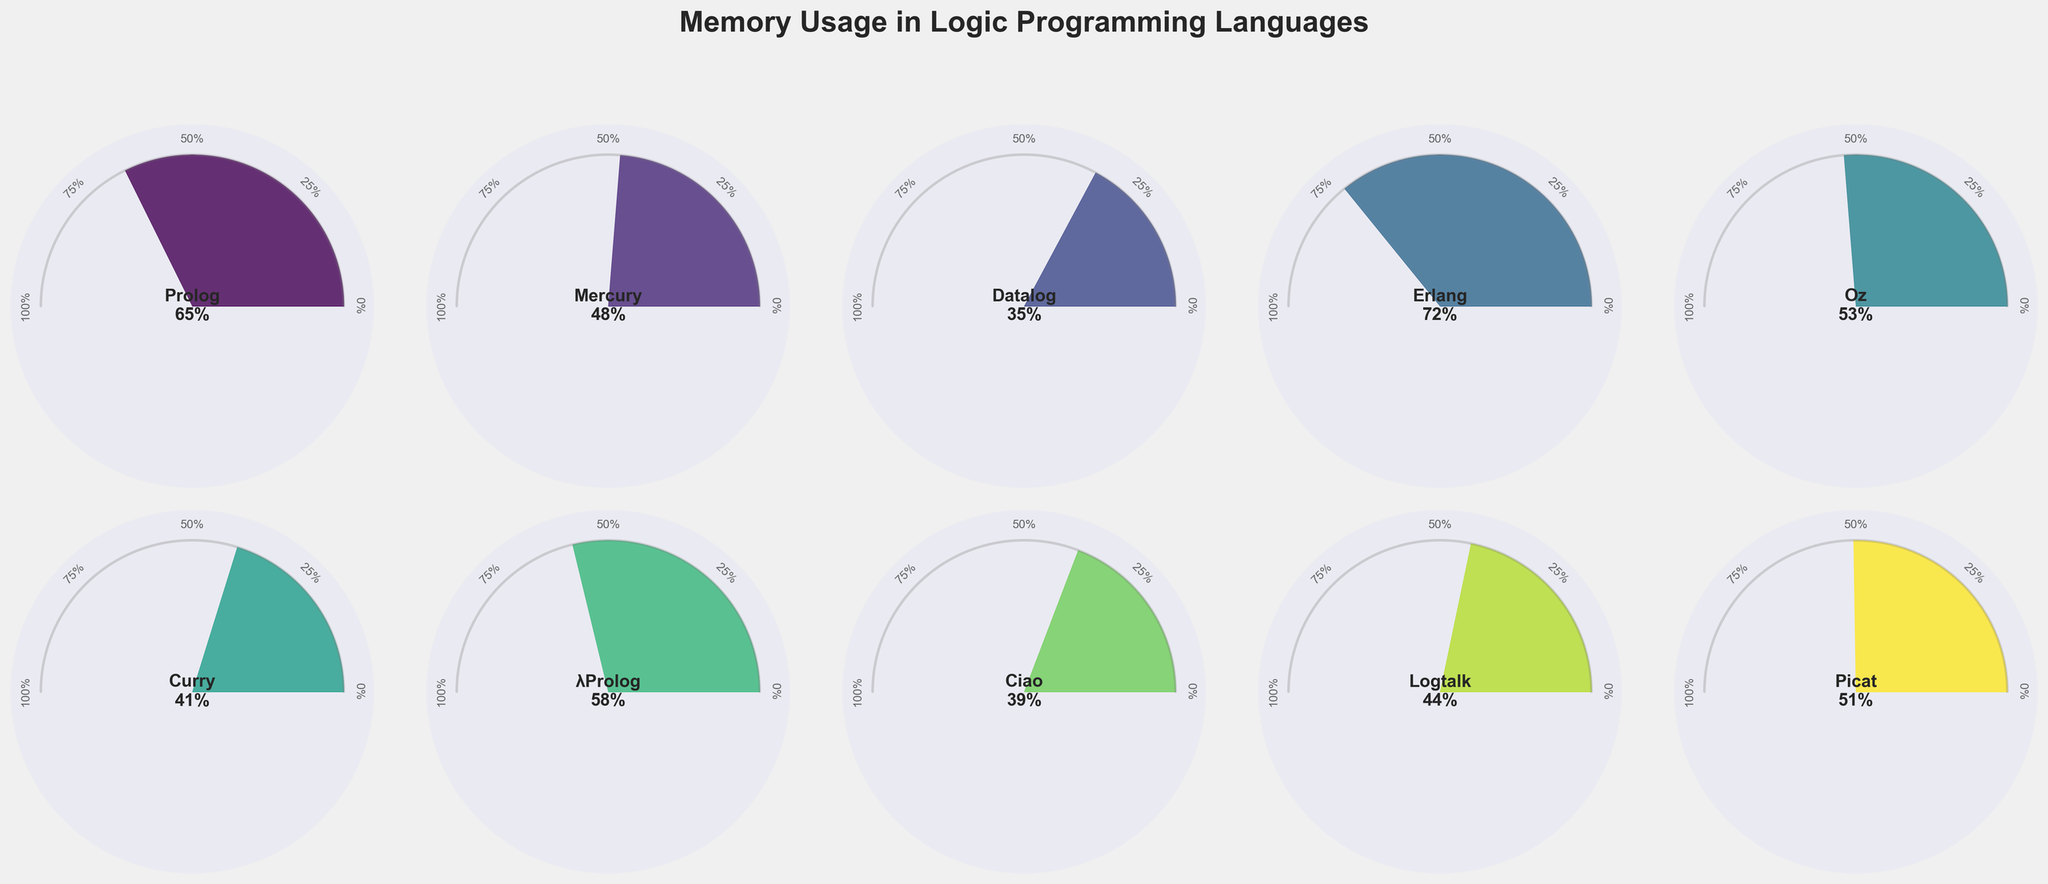Which logic programming language has the highest memory usage percentage? To find the language with the highest memory usage, scan the gauge charts and identify the one with the largest filled area. This corresponds to the language 'Erlang' that has 72% memory usage.
Answer: Erlang What is the average memory usage percentage across all languages? Add the memory usage percentages of all languages: 65 + 48 + 35 + 72 + 53 + 41 + 58 + 39 + 44 + 51 = 506. Then, divide by the number of languages, which is 10. The average memory usage is 506/10 = 50.6%.
Answer: 50.6% How many languages have a memory usage percentage higher than 50%? Count the number of gauge charts where the memory usage percentage exceeds 50%. The languages are Prolog (65%), Erlang (72%), Oz (53%), λProlog (58%), and Picat (51%), which total 5 languages.
Answer: 5 What is the combined memory usage percentage of Prolog and Picat? Sum the memory usage percentages of Prolog (65%) and Picat (51%): 65 + 51 = 116.
Answer: 116% Which language has the closest memory usage percentage to the average memory usage? First, recall the calculated average memory usage percentage (50.6%). Compare this with each language's memory usage: Prolog (65%), Mercury (48%), Datalog (35%), Erlang (72%), Oz (53%), Curry (41%), λProlog (58%), Ciao (39%), Logtalk (44%), Picat (51%). Picat with 51% is the closest to 50.6%.
Answer: Picat Among Erlang and λProlog, which has a higher memory usage percentage and by how much? Compare the memory usage percentages: Erlang (72%) and λProlog (58%). Calculate the difference: 72 - 58 = 14. Erlang has a higher memory usage by 14%.
Answer: Erlang by 14% How many languages fall within the memory usage range of 40% to 60%? Identify the languages within the specified range: Mercury (48%), Oz (53%), Curry (41%), λProlog (58%), Picat (51%), Logtalk (44%). There are 6 languages within this range.
Answer: 6 